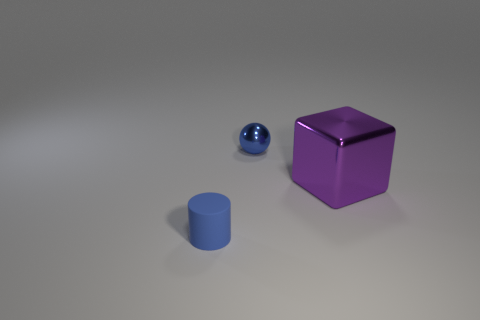How many other objects are the same material as the cube?
Make the answer very short. 1. Is there any other thing that is the same size as the purple metallic cube?
Your response must be concise. No. The purple shiny thing is what shape?
Offer a very short reply. Cube. Are there fewer blue objects that are to the left of the small metal object than objects that are on the right side of the blue rubber cylinder?
Make the answer very short. Yes. How many large purple metallic cubes are behind the blue object that is behind the large block?
Make the answer very short. 0. Are there any large green blocks?
Offer a terse response. No. Is there a blue thing that has the same material as the purple object?
Ensure brevity in your answer.  Yes. Is the number of purple metallic cubes that are left of the tiny blue cylinder greater than the number of cylinders that are right of the blue sphere?
Provide a succinct answer. No. Do the matte thing and the blue ball have the same size?
Your answer should be very brief. Yes. The metal object that is in front of the small blue thing behind the small blue cylinder is what color?
Your answer should be compact. Purple. 